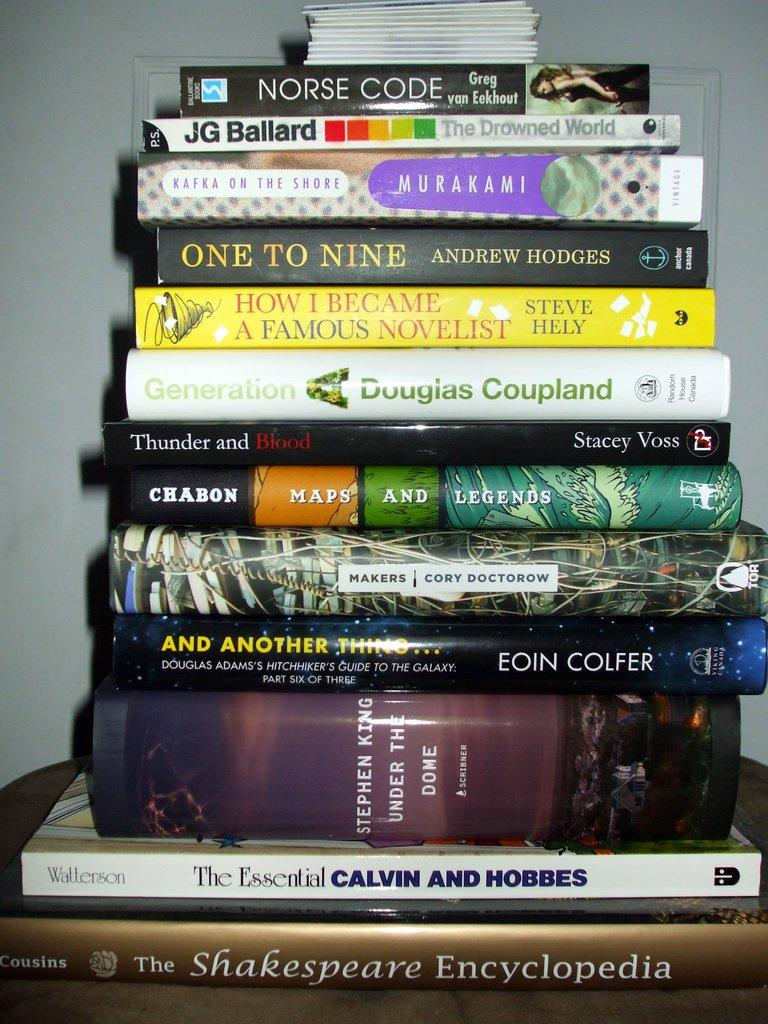What objects are on the table in the image? There are books on the table in the image. What can be found on the books? There is text on the books. Can you describe any specific images on the books? There is a picture of a woman on one of the books. What can be seen in the background of the image? There is a wall visible in the background of the image. What type of dog can be seen playing with a spoon in the image? There is no dog or spoon present in the image; it only features books on a table with a wall in the background. 